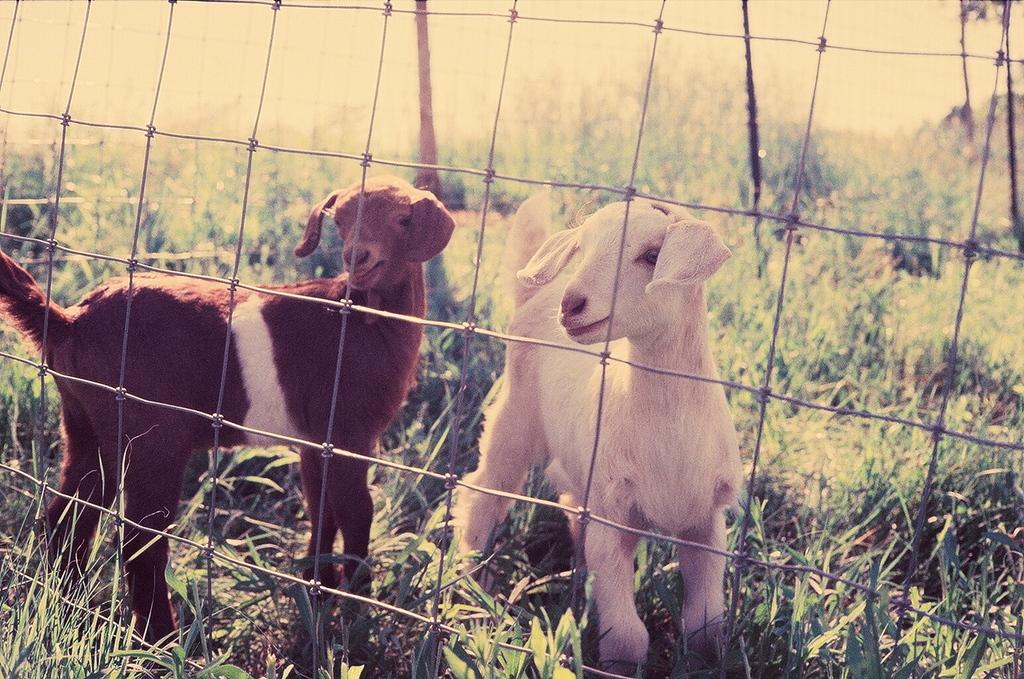How many goats are present in the image? There are two goats in the image. What type of vegetation can be seen on the ground in the image? Plants and grass are visible on the ground in the image. What is located in the front of the image? There is a fencing in the front of the image. What is the level of wealth displayed by the goats in the image? The level of wealth cannot be determined from the image, as goats do not possess wealth. 